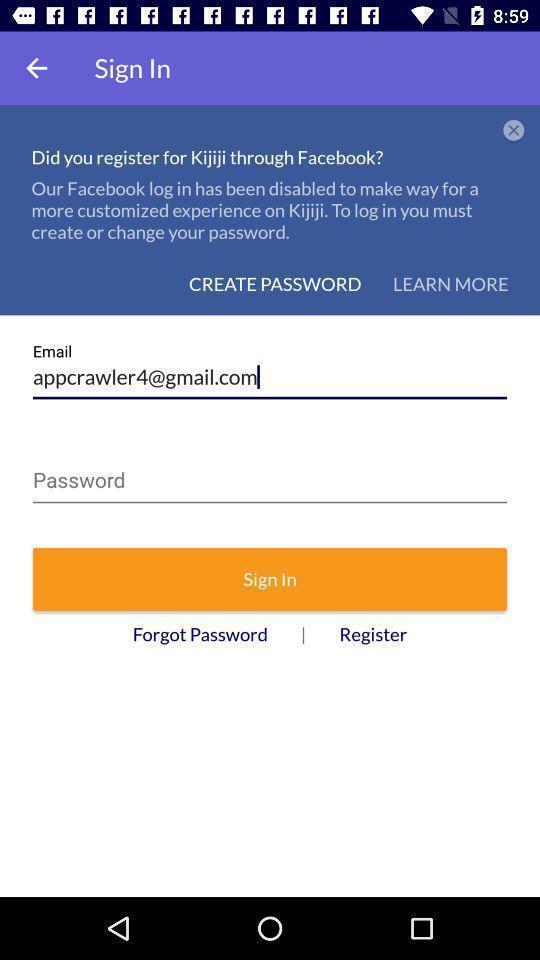What can you discern from this picture? Sign in page. 